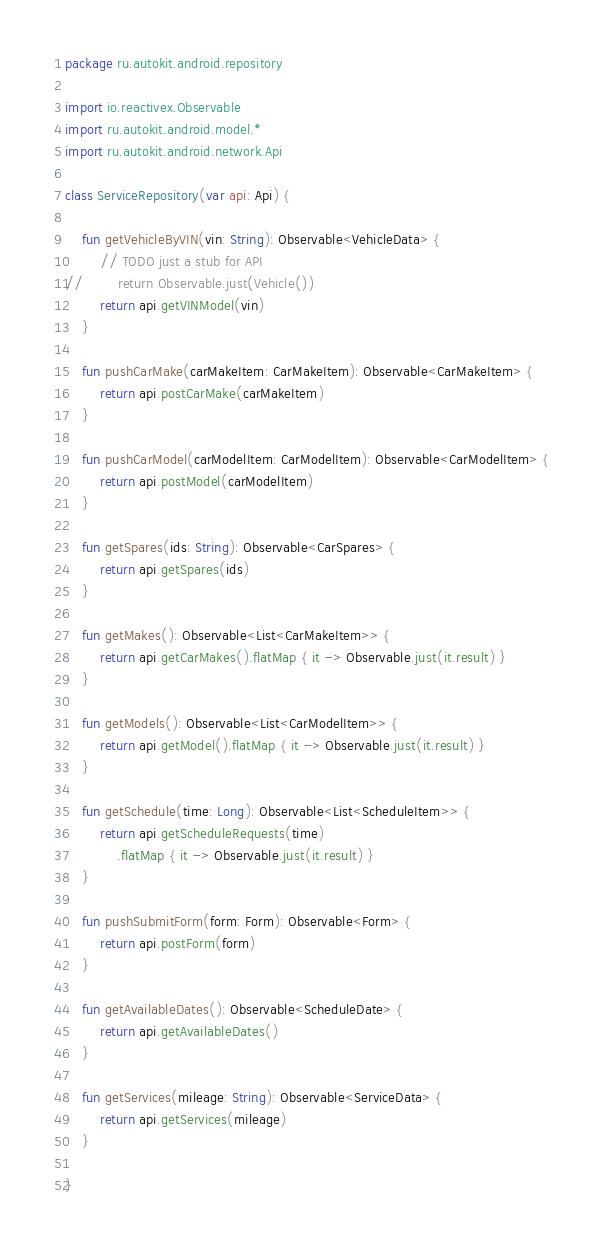Convert code to text. <code><loc_0><loc_0><loc_500><loc_500><_Kotlin_>package ru.autokit.android.repository

import io.reactivex.Observable
import ru.autokit.android.model.*
import ru.autokit.android.network.Api

class ServiceRepository(var api: Api) {

    fun getVehicleByVIN(vin: String): Observable<VehicleData> {
        // TODO just a stub for API
//        return Observable.just(Vehicle())
        return api.getVINModel(vin)
    }

    fun pushCarMake(carMakeItem: CarMakeItem): Observable<CarMakeItem> {
        return api.postCarMake(carMakeItem)
    }

    fun pushCarModel(carModelItem: CarModelItem): Observable<CarModelItem> {
        return api.postModel(carModelItem)
    }

    fun getSpares(ids: String): Observable<CarSpares> {
        return api.getSpares(ids)
    }

    fun getMakes(): Observable<List<CarMakeItem>> {
        return api.getCarMakes().flatMap { it -> Observable.just(it.result) }
    }

    fun getModels(): Observable<List<CarModelItem>> {
        return api.getModel().flatMap { it -> Observable.just(it.result) }
    }

    fun getSchedule(time: Long): Observable<List<ScheduleItem>> {
        return api.getScheduleRequests(time)
            .flatMap { it -> Observable.just(it.result) }
    }

    fun pushSubmitForm(form: Form): Observable<Form> {
        return api.postForm(form)
    }

    fun getAvailableDates(): Observable<ScheduleDate> {
        return api.getAvailableDates()
    }

    fun getServices(mileage: String): Observable<ServiceData> {
        return api.getServices(mileage)
    }

}</code> 